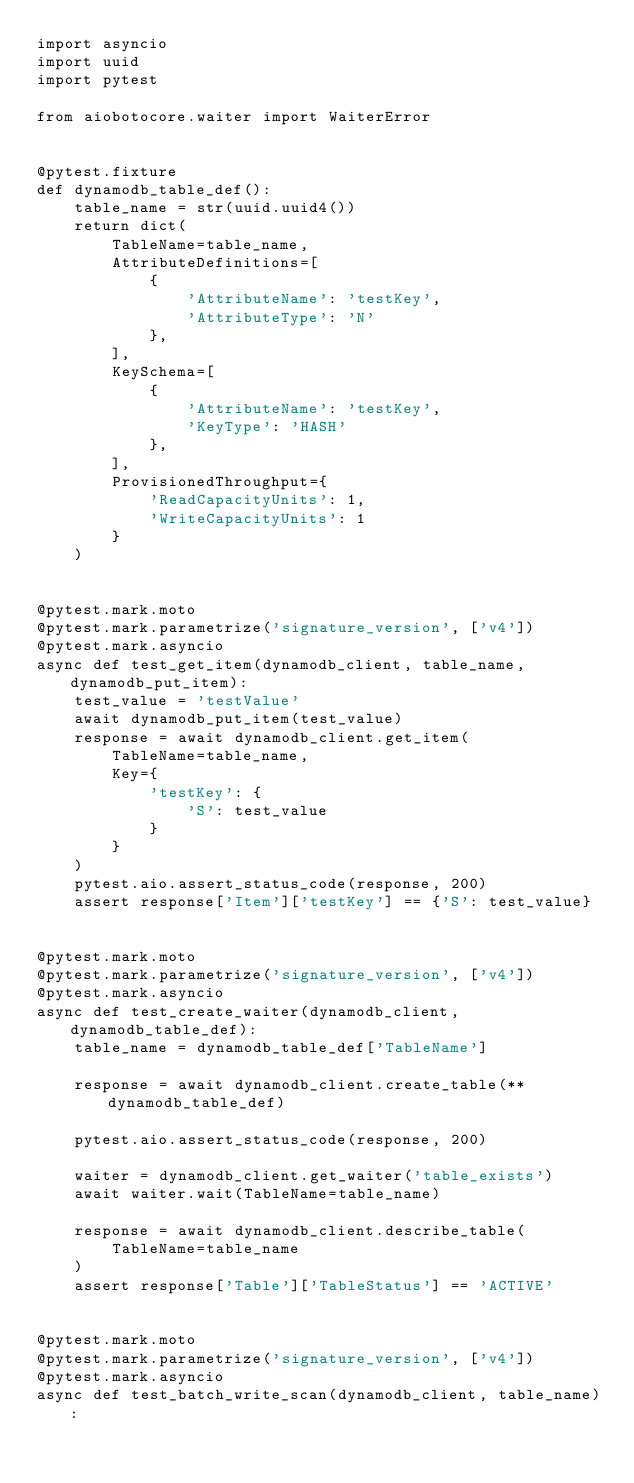<code> <loc_0><loc_0><loc_500><loc_500><_Python_>import asyncio
import uuid
import pytest

from aiobotocore.waiter import WaiterError


@pytest.fixture
def dynamodb_table_def():
    table_name = str(uuid.uuid4())
    return dict(
        TableName=table_name,
        AttributeDefinitions=[
            {
                'AttributeName': 'testKey',
                'AttributeType': 'N'
            },
        ],
        KeySchema=[
            {
                'AttributeName': 'testKey',
                'KeyType': 'HASH'
            },
        ],
        ProvisionedThroughput={
            'ReadCapacityUnits': 1,
            'WriteCapacityUnits': 1
        }
    )


@pytest.mark.moto
@pytest.mark.parametrize('signature_version', ['v4'])
@pytest.mark.asyncio
async def test_get_item(dynamodb_client, table_name, dynamodb_put_item):
    test_value = 'testValue'
    await dynamodb_put_item(test_value)
    response = await dynamodb_client.get_item(
        TableName=table_name,
        Key={
            'testKey': {
                'S': test_value
            }
        }
    )
    pytest.aio.assert_status_code(response, 200)
    assert response['Item']['testKey'] == {'S': test_value}


@pytest.mark.moto
@pytest.mark.parametrize('signature_version', ['v4'])
@pytest.mark.asyncio
async def test_create_waiter(dynamodb_client, dynamodb_table_def):
    table_name = dynamodb_table_def['TableName']

    response = await dynamodb_client.create_table(**dynamodb_table_def)

    pytest.aio.assert_status_code(response, 200)

    waiter = dynamodb_client.get_waiter('table_exists')
    await waiter.wait(TableName=table_name)

    response = await dynamodb_client.describe_table(
        TableName=table_name
    )
    assert response['Table']['TableStatus'] == 'ACTIVE'


@pytest.mark.moto
@pytest.mark.parametrize('signature_version', ['v4'])
@pytest.mark.asyncio
async def test_batch_write_scan(dynamodb_client, table_name):</code> 